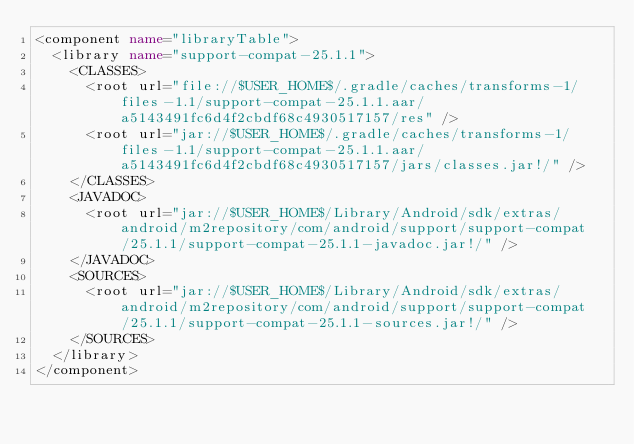Convert code to text. <code><loc_0><loc_0><loc_500><loc_500><_XML_><component name="libraryTable">
  <library name="support-compat-25.1.1">
    <CLASSES>
      <root url="file://$USER_HOME$/.gradle/caches/transforms-1/files-1.1/support-compat-25.1.1.aar/a5143491fc6d4f2cbdf68c4930517157/res" />
      <root url="jar://$USER_HOME$/.gradle/caches/transforms-1/files-1.1/support-compat-25.1.1.aar/a5143491fc6d4f2cbdf68c4930517157/jars/classes.jar!/" />
    </CLASSES>
    <JAVADOC>
      <root url="jar://$USER_HOME$/Library/Android/sdk/extras/android/m2repository/com/android/support/support-compat/25.1.1/support-compat-25.1.1-javadoc.jar!/" />
    </JAVADOC>
    <SOURCES>
      <root url="jar://$USER_HOME$/Library/Android/sdk/extras/android/m2repository/com/android/support/support-compat/25.1.1/support-compat-25.1.1-sources.jar!/" />
    </SOURCES>
  </library>
</component></code> 